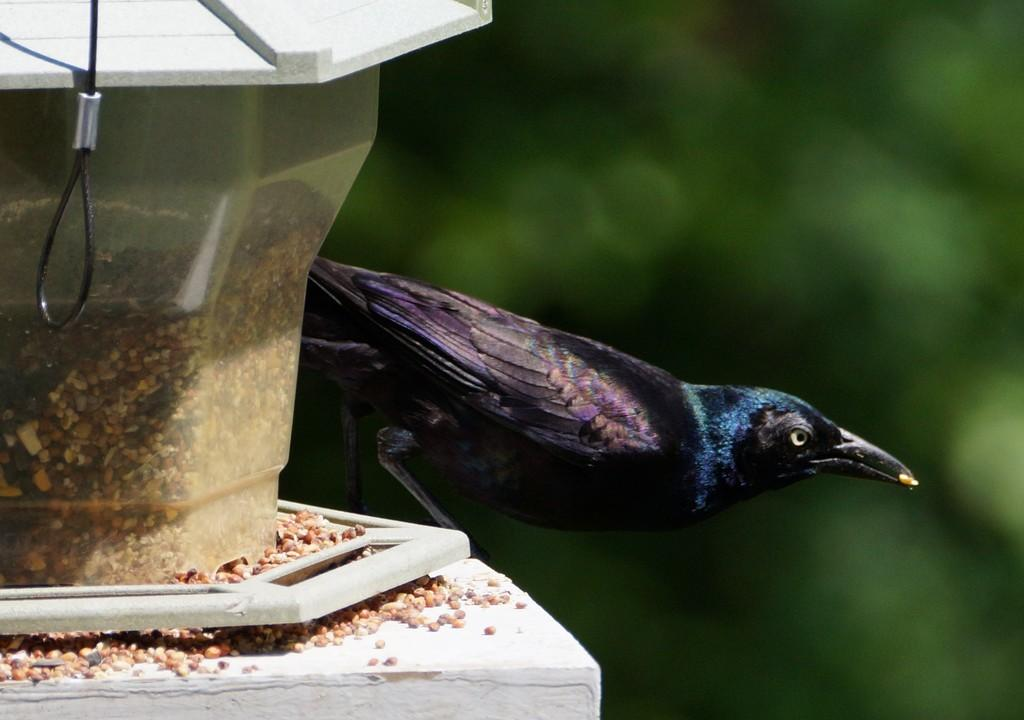What is the main subject in the foreground of the image? There is a bird in the foreground of the image. Where is the bird located? The bird is on a bird feeding station. Can you describe the background of the image? The background of the image is blurred. What type of boat can be seen in the background of the image? There is no boat present in the image; the background is blurred. How many pieces of popcorn are on the bird feeding station? The provided facts do not mention popcorn, so it cannot be determined from the image. 